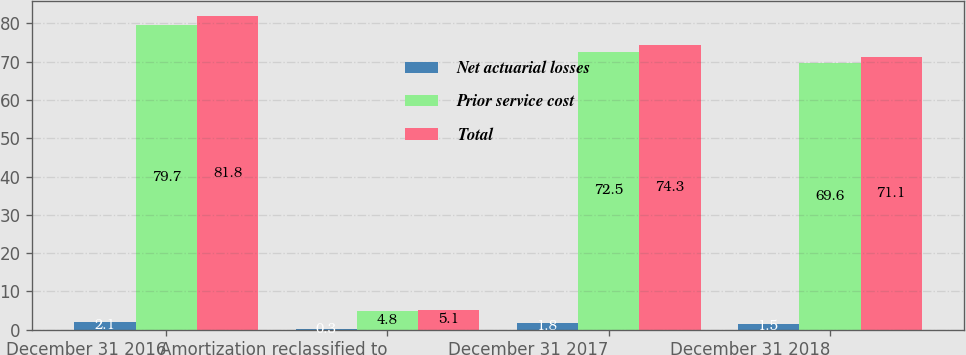<chart> <loc_0><loc_0><loc_500><loc_500><stacked_bar_chart><ecel><fcel>December 31 2016<fcel>Amortization reclassified to<fcel>December 31 2017<fcel>December 31 2018<nl><fcel>Net actuarial losses<fcel>2.1<fcel>0.3<fcel>1.8<fcel>1.5<nl><fcel>Prior service cost<fcel>79.7<fcel>4.8<fcel>72.5<fcel>69.6<nl><fcel>Total<fcel>81.8<fcel>5.1<fcel>74.3<fcel>71.1<nl></chart> 